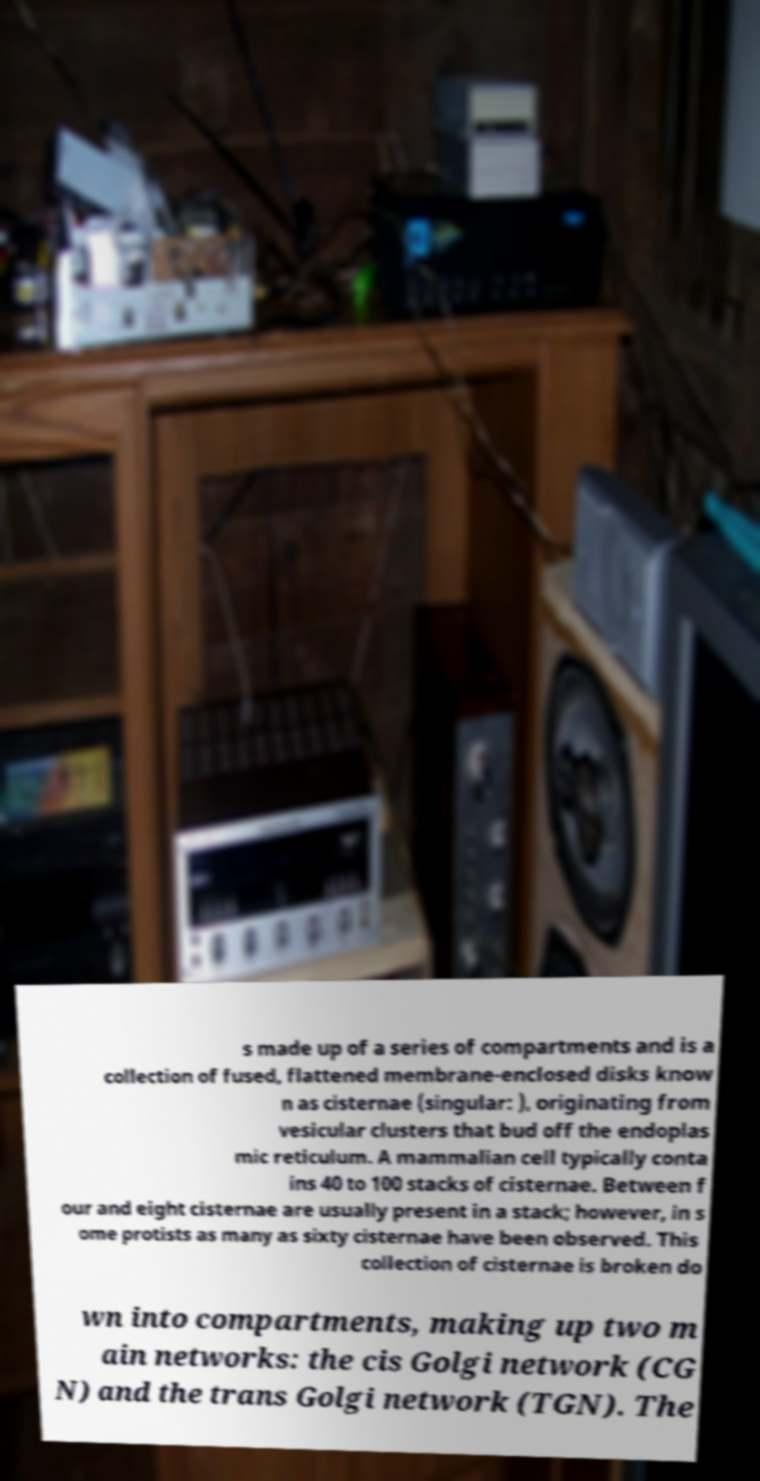What messages or text are displayed in this image? I need them in a readable, typed format. s made up of a series of compartments and is a collection of fused, flattened membrane-enclosed disks know n as cisternae (singular: ), originating from vesicular clusters that bud off the endoplas mic reticulum. A mammalian cell typically conta ins 40 to 100 stacks of cisternae. Between f our and eight cisternae are usually present in a stack; however, in s ome protists as many as sixty cisternae have been observed. This collection of cisternae is broken do wn into compartments, making up two m ain networks: the cis Golgi network (CG N) and the trans Golgi network (TGN). The 